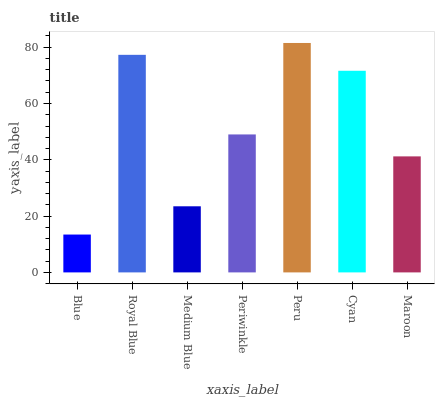Is Royal Blue the minimum?
Answer yes or no. No. Is Royal Blue the maximum?
Answer yes or no. No. Is Royal Blue greater than Blue?
Answer yes or no. Yes. Is Blue less than Royal Blue?
Answer yes or no. Yes. Is Blue greater than Royal Blue?
Answer yes or no. No. Is Royal Blue less than Blue?
Answer yes or no. No. Is Periwinkle the high median?
Answer yes or no. Yes. Is Periwinkle the low median?
Answer yes or no. Yes. Is Royal Blue the high median?
Answer yes or no. No. Is Blue the low median?
Answer yes or no. No. 